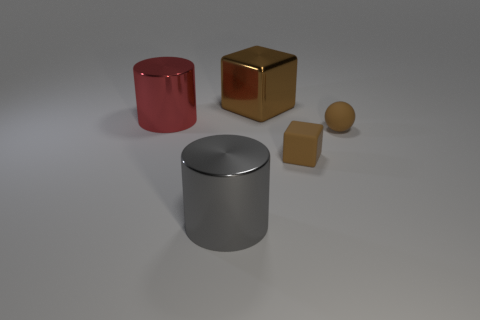Subtract all cubes. How many objects are left? 3 Subtract 1 spheres. How many spheres are left? 0 Add 3 cylinders. How many objects exist? 8 Subtract all cyan cylinders. Subtract all cyan balls. How many cylinders are left? 2 Subtract all purple cylinders. How many red blocks are left? 0 Subtract all small brown spheres. Subtract all brown balls. How many objects are left? 3 Add 4 brown matte objects. How many brown matte objects are left? 6 Add 1 tiny matte cubes. How many tiny matte cubes exist? 2 Subtract 1 gray cylinders. How many objects are left? 4 